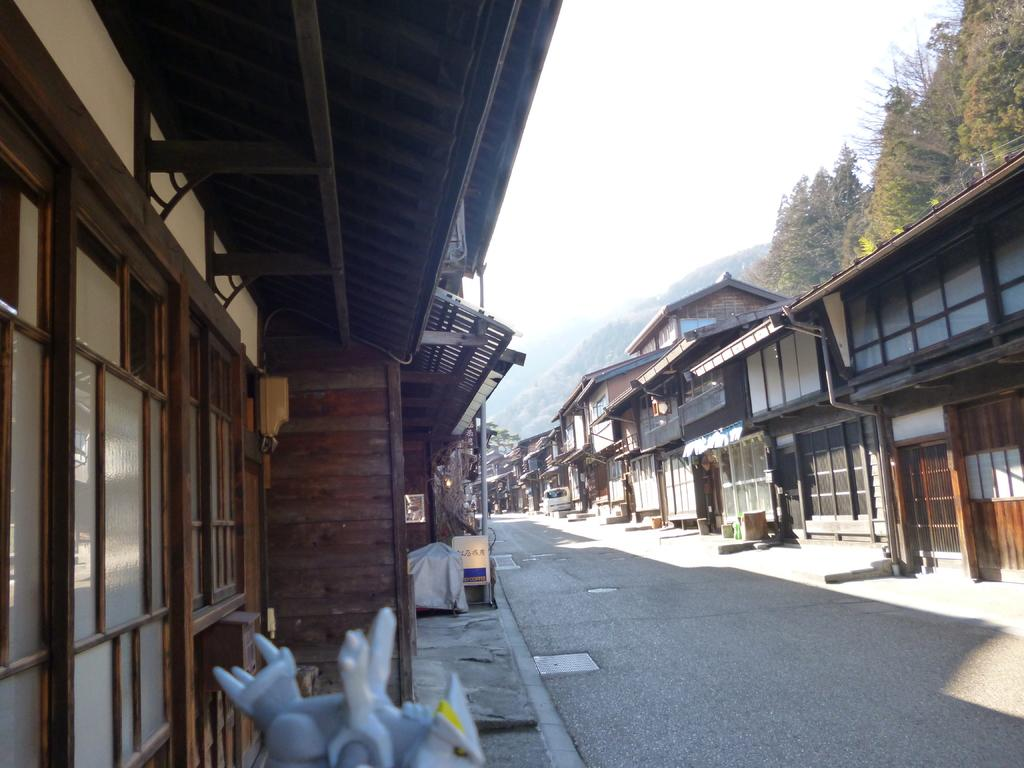What type of structures are present in the image? There are stalls in the image. What colors are the stalls? The stalls are in brown, gray, and white colors. What can be seen in the background of the image? There are trees and the sky visible in the background of the image. What is the color of the trees? The trees are green. What is the color of the sky in the image? The sky is in a white color. What type of bone is being used as a decoration on the stalls in the image? There is no bone present in the image; the stalls are in brown, gray, and white colors. What position are the trees in the image? The trees are not in a specific position; they are simply visible in the background of the image. 